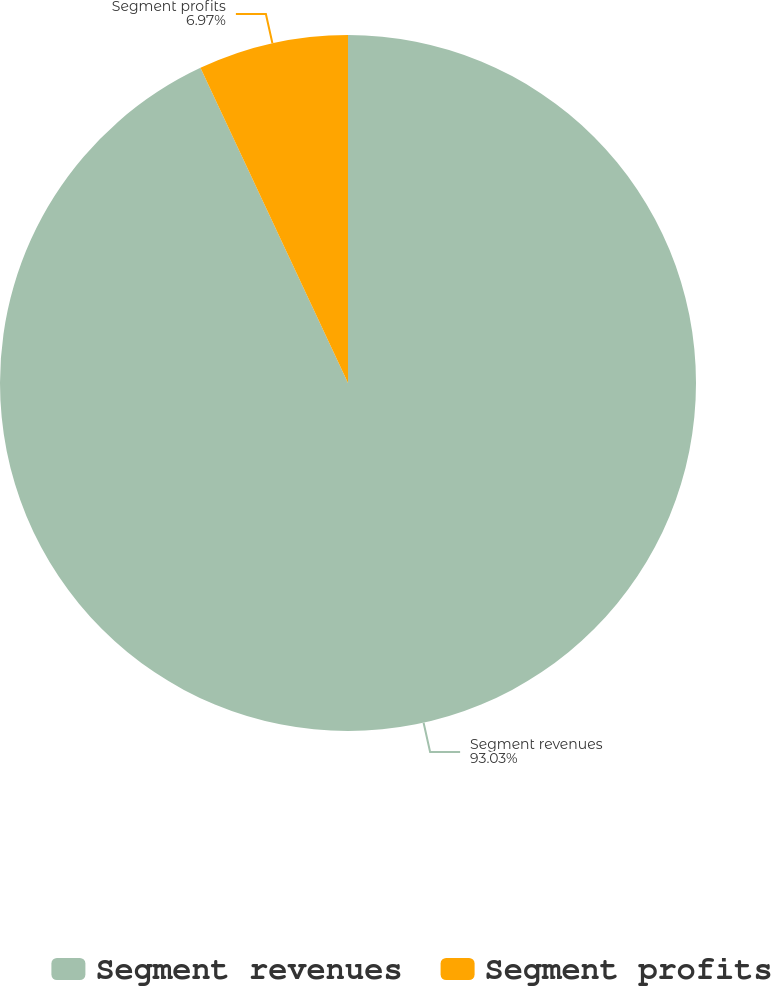Convert chart. <chart><loc_0><loc_0><loc_500><loc_500><pie_chart><fcel>Segment revenues<fcel>Segment profits<nl><fcel>93.03%<fcel>6.97%<nl></chart> 